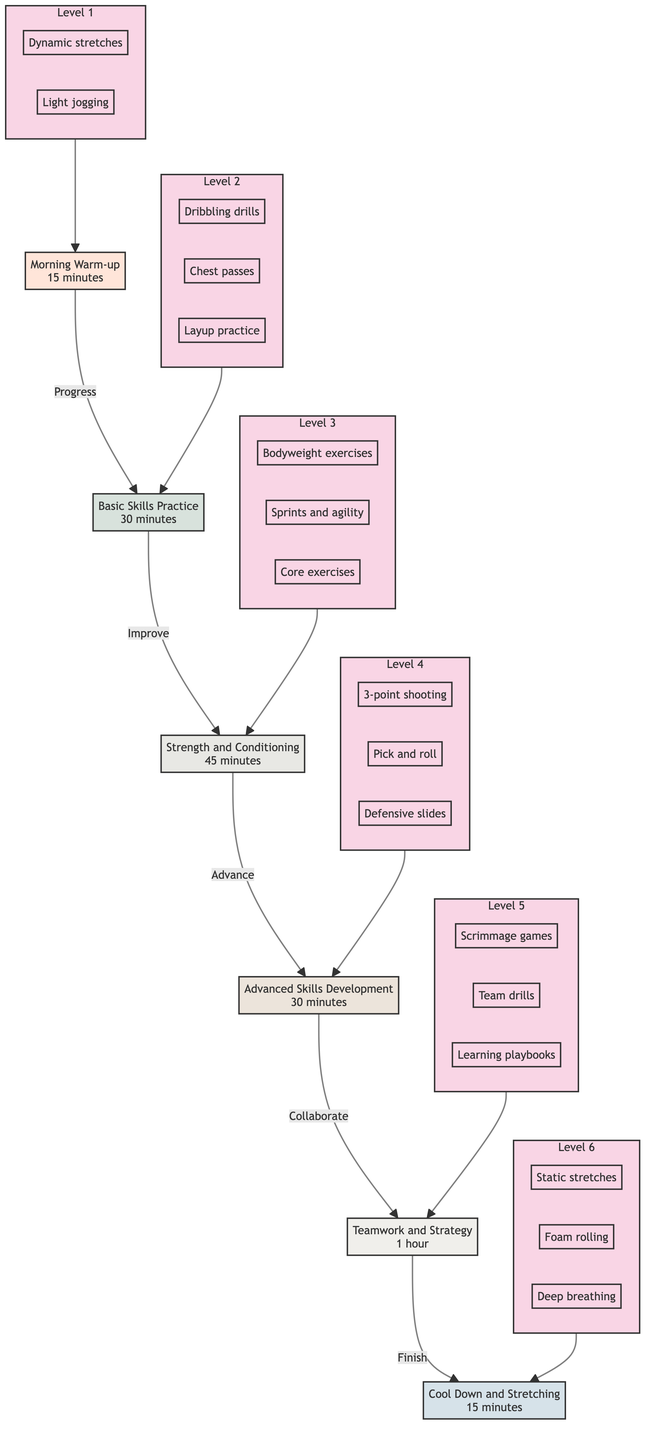What is the first activity in the training routine? The diagram indicates that the first activity (bottom level) is "Morning Warm-up."
Answer: Morning Warm-up How long does the Basic Skills Practice last? According to the diagram, the Basic Skills Practice has a duration of "30 minutes."
Answer: 30 minutes What comes after Strength and Conditioning? The flow chart shows that after Strength and Conditioning, the next activity is "Advanced Skills Development."
Answer: Advanced Skills Development How many total levels are there in the training routine? The diagram represents a total of six levels, from Morning Warm-up to Cool Down and Stretching.
Answer: 6 What is the duration of the Cool Down and Stretching? The diagram states that the duration for Cool Down and Stretching is "15 minutes."
Answer: 15 minutes What type of practice is included in Teamwork and Strategy? The flow chart indicates that "Scrimmage games" are part of the Teamwork and Strategy activities.
Answer: Scrimmage games Which activity involves learning playbooks? The diagram specifies that "Reviewing and learning playbooks" is an activity under Teamwork and Strategy.
Answer: Reviewing and learning playbooks Which two activities are included in Strength and Conditioning? From the Strength and Conditioning section, it includes "Bodyweight exercises" and "Sprints and agility ladder drills."
Answer: Bodyweight exercises, Sprints and agility ladder drills What is the relationship between Advanced Skills Development and Teamwork and Strategy? In the diagram, Advanced Skills Development leads up to Teamwork and Strategy, indicating a progression in skills before teamwork exercises.
Answer: Progression in skills before teamwork exercises 